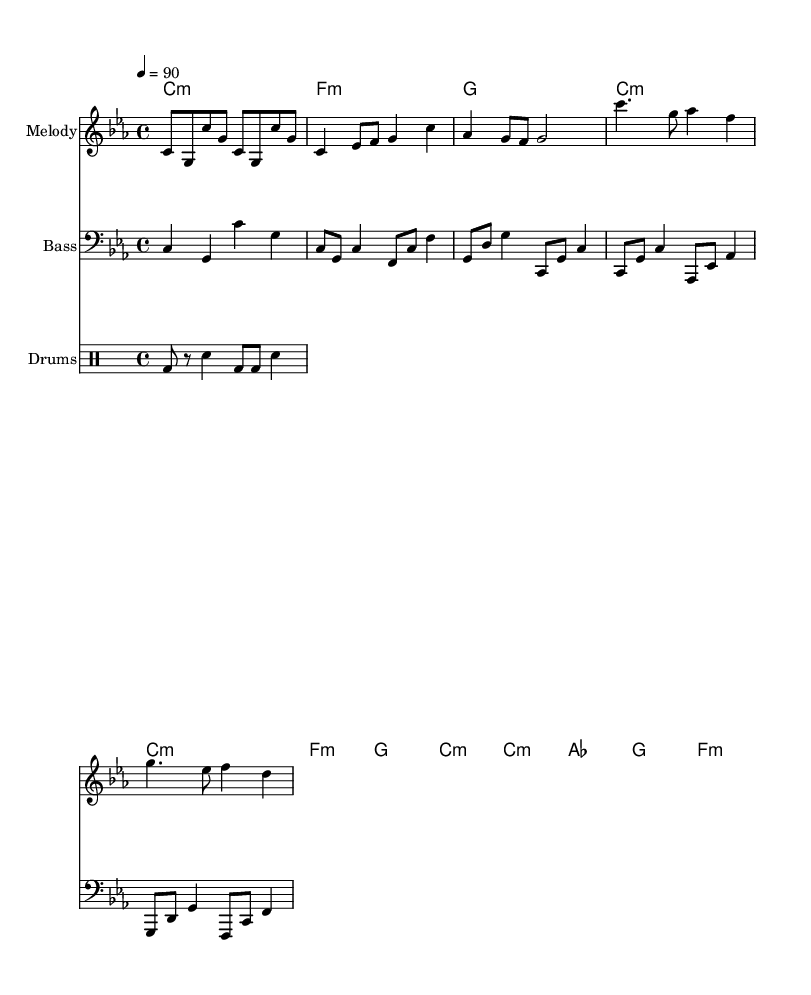What is the key signature of this music? The key signature indicates the key of C minor, which has three flats: B flat, E flat, and A flat. This is deduced from the notation at the beginning of the score that specifies the key signature.
Answer: C minor What is the time signature of this piece? The time signature, located at the beginning of the score, is 4/4 which means there are four beats per measure and the quarter note gets one beat. This can be identified by the "4" above and below the other "4" in the notation.
Answer: 4/4 What is the tempo marking of this music? The tempo is indicated at the start of the score as 4 equals 90, which signifies a moderate tempo of 90 beats per minute. This number indicates how many beats occur in a minute, helping musicians understand how fast to play.
Answer: 90 How many measures are in the intro section? The intro consists of 4 measures, which can be counted by identifying the individual segments between the vertical bar lines in the score. Each segment separated by a bar line represents a measure.
Answer: 4 What is the first chord played in this music? The first chord indicated in the harmonies section is C minor, which can be found as the initial chord notation before the melody begins. It corresponds to the first bar of the music.
Answer: C minor What is the pattern of the drums in the intro? The drum pattern for the intro consists of a bass drum (bd) played on the first and last beats of the measure, followed by a snare drum (sn) on the second and fourth beats. This pattern is noted in the drum staff and implies a consistent rhythmic basis for the piece.
Answer: bass-sn What is the final chord in the chorus? The last chord in the chorus is F minor, identified at the end of the chorus section within the harmonies. It is the final chord played before moving back to other sections.
Answer: F minor 